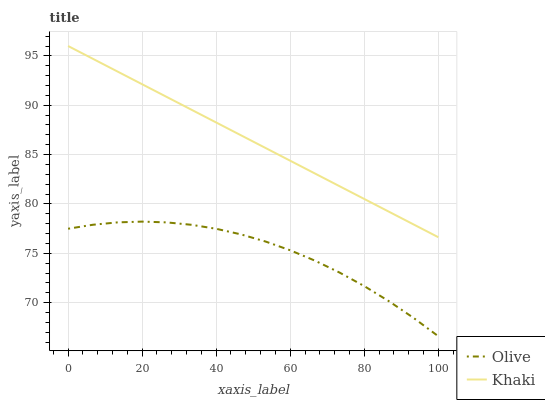Does Olive have the minimum area under the curve?
Answer yes or no. Yes. Does Khaki have the maximum area under the curve?
Answer yes or no. Yes. Does Khaki have the minimum area under the curve?
Answer yes or no. No. Is Khaki the smoothest?
Answer yes or no. Yes. Is Olive the roughest?
Answer yes or no. Yes. Is Khaki the roughest?
Answer yes or no. No. Does Olive have the lowest value?
Answer yes or no. Yes. Does Khaki have the lowest value?
Answer yes or no. No. Does Khaki have the highest value?
Answer yes or no. Yes. Is Olive less than Khaki?
Answer yes or no. Yes. Is Khaki greater than Olive?
Answer yes or no. Yes. Does Olive intersect Khaki?
Answer yes or no. No. 